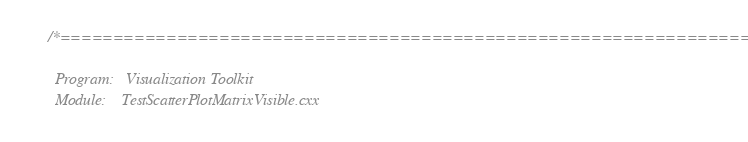Convert code to text. <code><loc_0><loc_0><loc_500><loc_500><_C++_>/*=========================================================================

  Program:   Visualization Toolkit
  Module:    TestScatterPlotMatrixVisible.cxx
</code> 